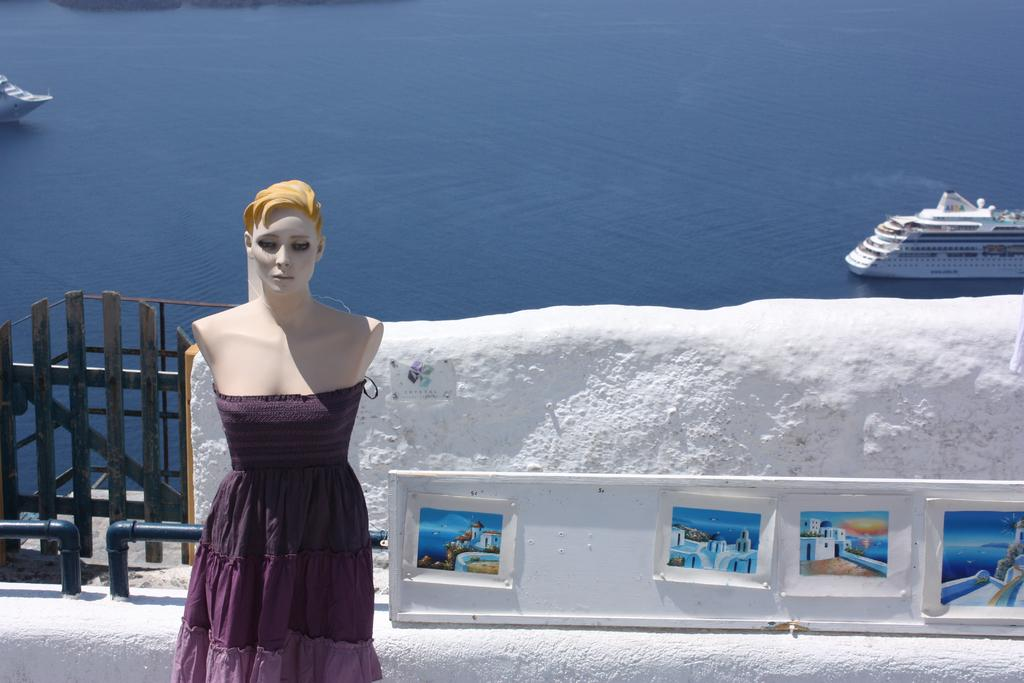What is the main subject in the image? There is a mannequin in the image. What can be seen in the background of the image? There is a ship on the water in the image. What type of structures are visible in the image? There are posts, a fence, and a wall visible in the image. How many dogs are present in the image? There are no dogs present in the image. What stage of development is the mannequin in the image? The mannequin is an inanimate object and does not have a development stage. 